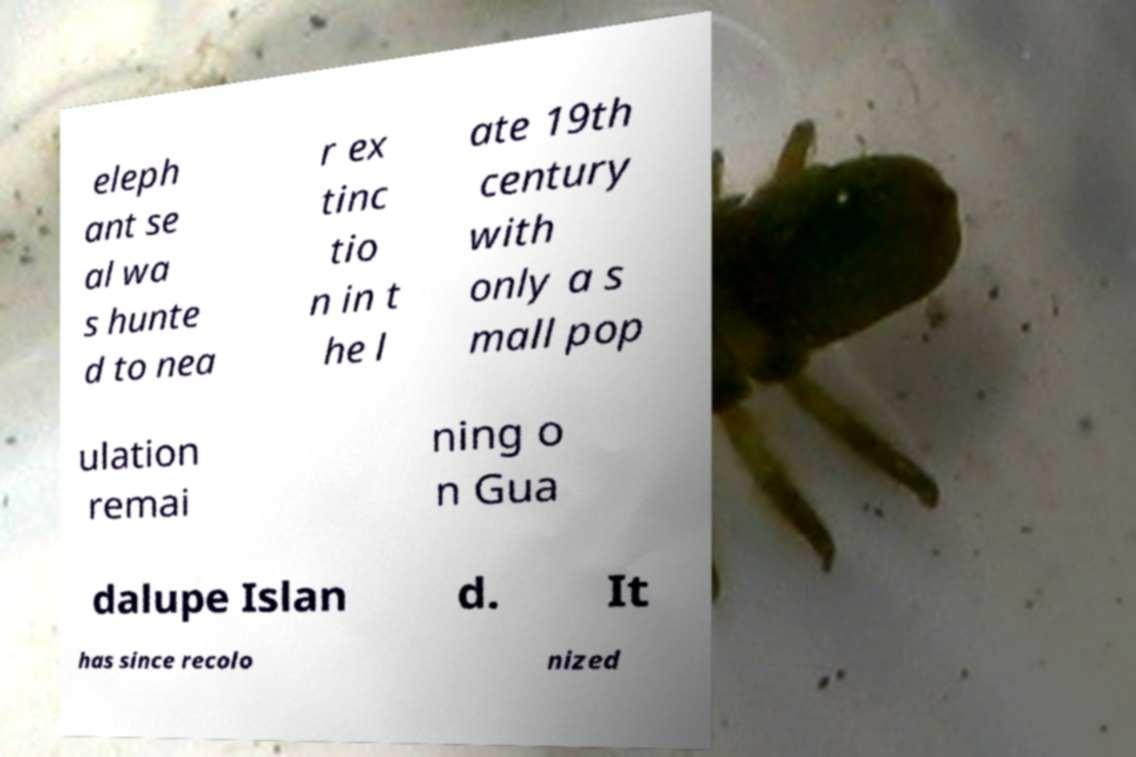I need the written content from this picture converted into text. Can you do that? eleph ant se al wa s hunte d to nea r ex tinc tio n in t he l ate 19th century with only a s mall pop ulation remai ning o n Gua dalupe Islan d. It has since recolo nized 